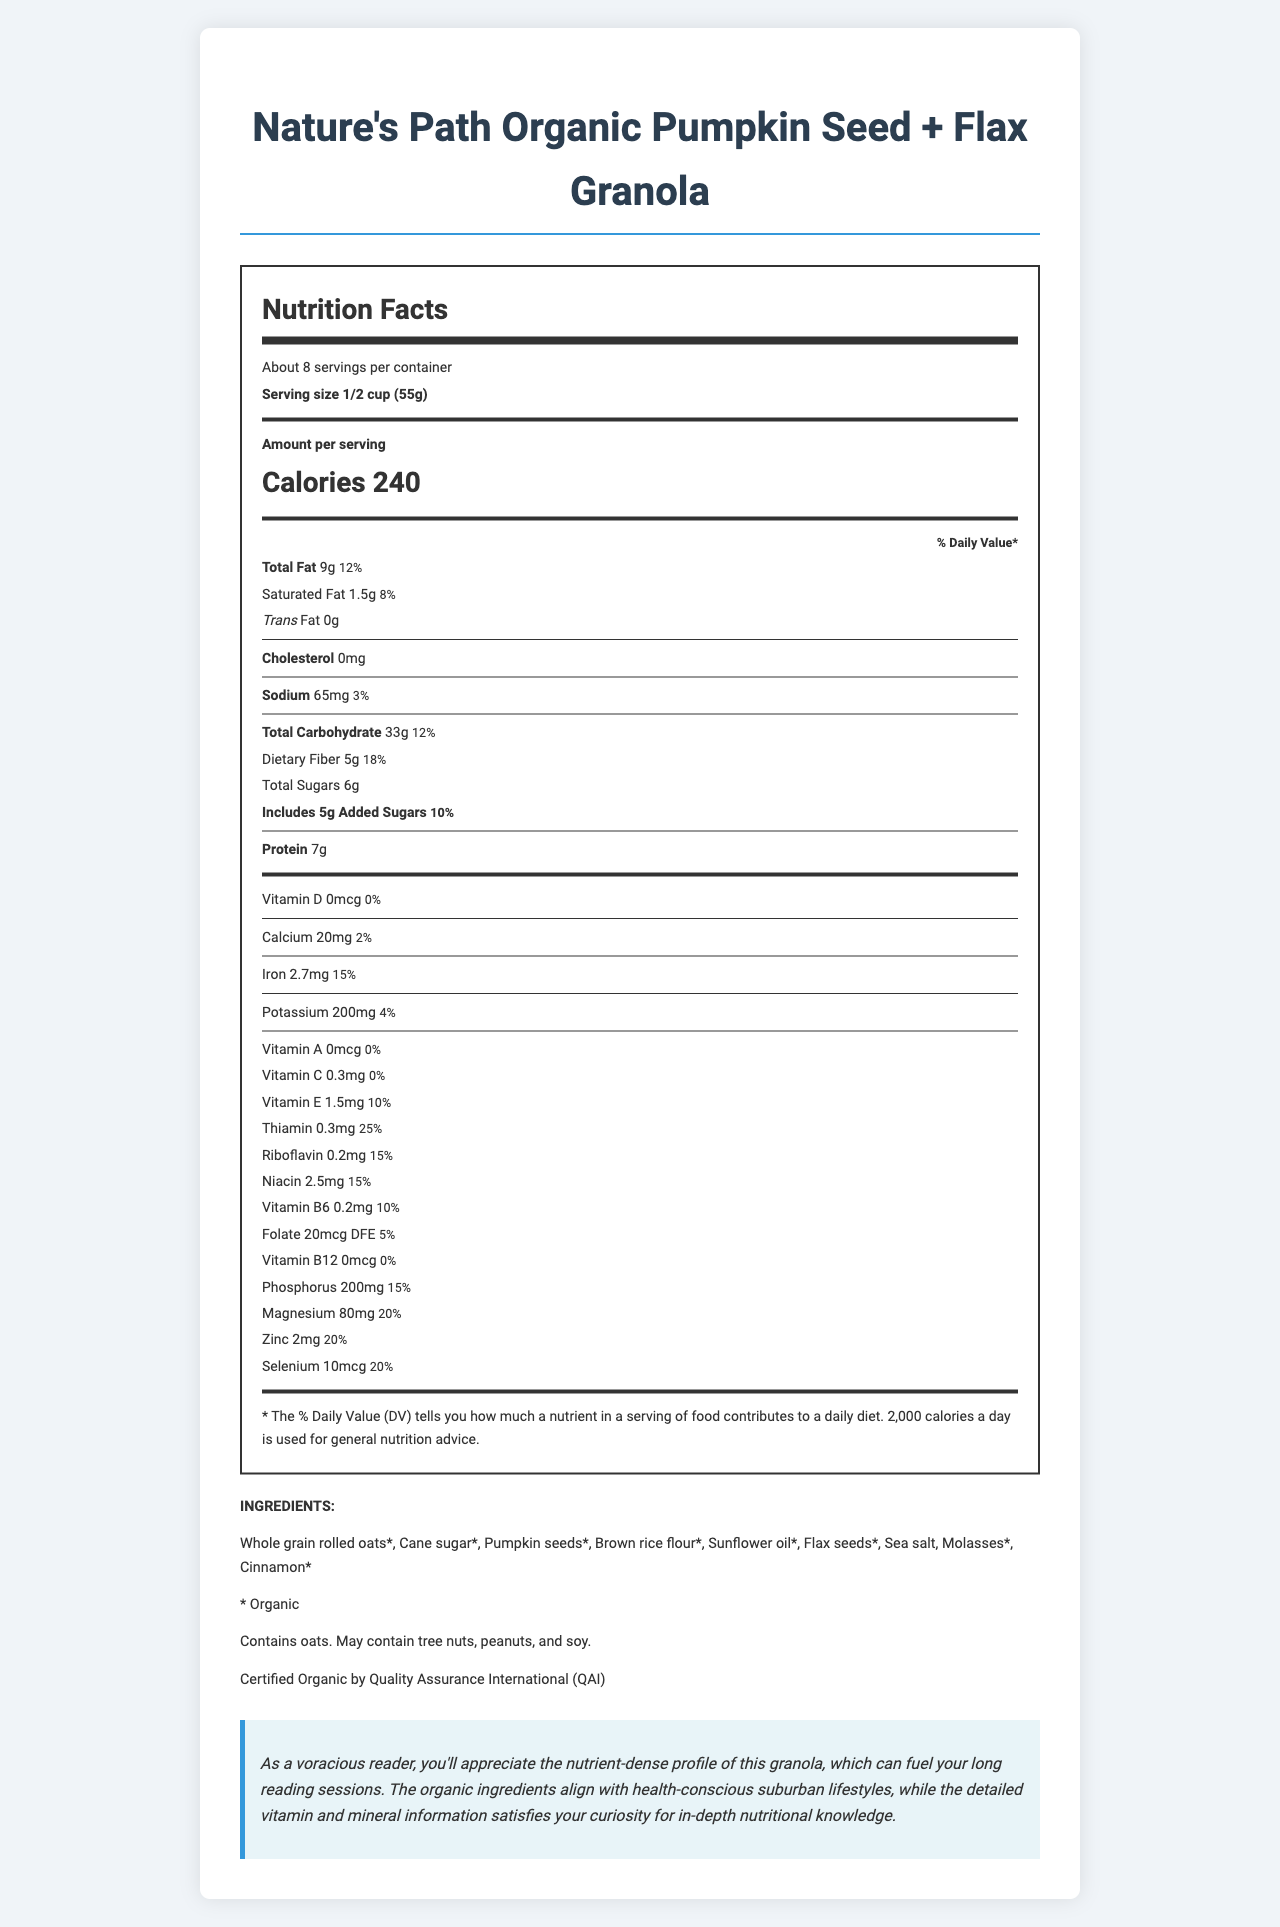How many calories are there in one serving of the granola? The calorie content per serving is explicitly listed as 240 calories in the document.
Answer: 240 What is the serving size for the granola? The serving size is shown as 1/2 cup or 55 grams per serving.
Answer: 1/2 cup (55g) How many servings are there per container of the granola? The document states that there are about 8 servings per container.
Answer: About 8 What is the amount of total fat per serving? The total fat content per serving is listed as 9 grams.
Answer: 9g How much dietary fiber is there per serving? The amount of dietary fiber per serving is provided as 5 grams.
Answer: 5g Does the granola contain any trans fat? The document states that the trans fat content is 0 grams.
Answer: No How much iron does one serving of the granola provide in percentage of daily value? A. 10% B. 12% C. 15% D. 20% The document shows that one serving provides 2.7mg of iron, which is 15% of the daily value.
Answer: C. 15% How much Vitamin D does one serving contain? The document states that the Vitamin D content is 0 micrograms.
Answer: 0mcg Which of the following minerals is present in the highest daily value percentage per serving? A. Calcium B. Phosphorus C. Zinc D. Magnesium Magnesium has a daily value of 20%, which is higher than Calcium (2%), Phosphorus (15%), and Zinc (20%).
Answer: D. Magnesium Is there any cholesterol in this granola? The cholesterol content is stated to be 0 milligrams.
Answer: No Summarize the main points of this Nutrition Facts Label. The document is a comprehensive nutrition facts label that details the nutritional content of the granola, focusing on serving size, calories, and both macro and micronutrients, along with ingredient and certification information.
Answer: The document provides nutrition information about Nature's Path Organic Pumpkin Seed + Flax Granola, detailing serving size, number of servings per container, calorie count, and various nutrient amounts per serving. It highlights both the macronutrients and micronutrients along with their percentages of daily value. The label also mentions the ingredients, allergen information, organic and non-GMO certifications, and appeals to health-conscious, curious readers. What is the percentage daily value of Vitamin C per serving? The document lists the amount of Vitamin C per serving as 0.3mg, which equates to 0% of the daily value.
Answer: 0% Can you find out the granola's manufacturing location from the document? The document does not provide any information about the manufacturing location of the granola.
Answer: Not enough information What ingredient is listed first in the granola? The first ingredient listed is Whole grain rolled oats.
Answer: Whole grain rolled oats How much sodium is there per serving in milligrams? The sodium content per serving is listed as 65 milligrams.
Answer: 65mg Does this granola contain any added sugars? The document lists that the granola includes 5 grams of added sugars per serving.
Answer: Yes What is the amount and daily value percentage of Thiamin per serving? One serving contains 0.3mg of Thiamin, which is 25% of the daily value.
Answer: 0.3mg / 25% 